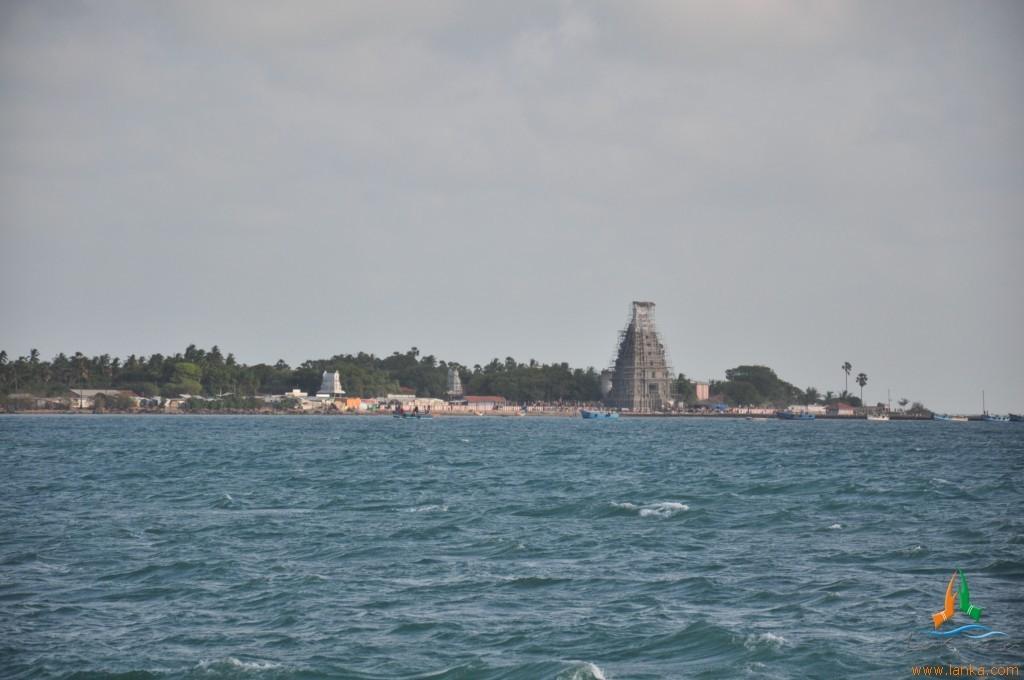Please provide a concise description of this image. There are boats on the water. Here we can see trees, houses, and ancient architecture. In the background we can see sky. 